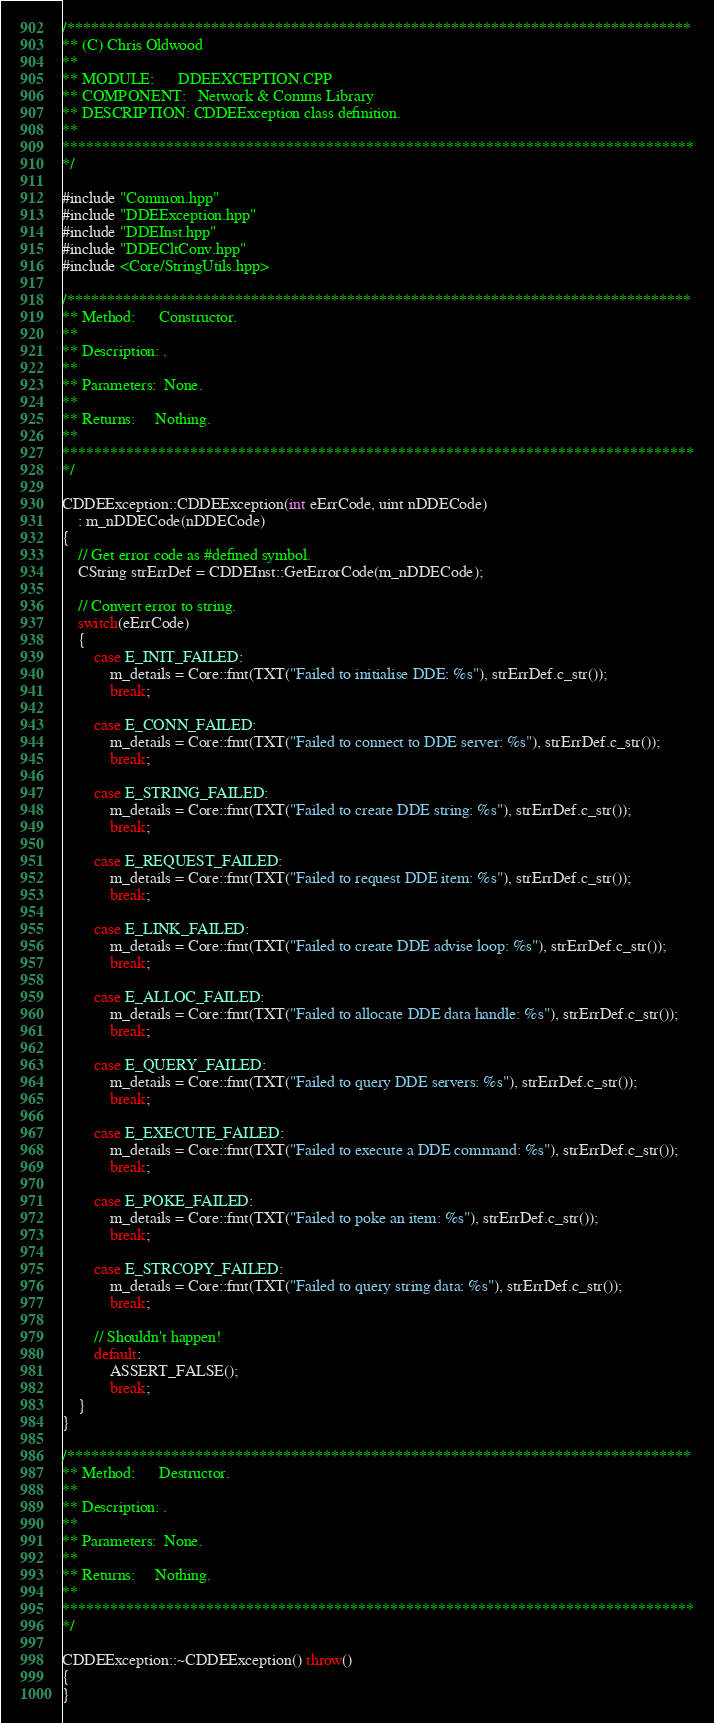<code> <loc_0><loc_0><loc_500><loc_500><_C++_>/******************************************************************************
** (C) Chris Oldwood
**
** MODULE:		DDEEXCEPTION.CPP
** COMPONENT:	Network & Comms Library
** DESCRIPTION:	CDDEException class definition.
**
*******************************************************************************
*/

#include "Common.hpp"
#include "DDEException.hpp"
#include "DDEInst.hpp"
#include "DDECltConv.hpp"
#include <Core/StringUtils.hpp>

/******************************************************************************
** Method:		Constructor.
**
** Description:	.
**
** Parameters:	None.
**
** Returns:		Nothing.
**
*******************************************************************************
*/

CDDEException::CDDEException(int eErrCode, uint nDDECode)
	: m_nDDECode(nDDECode)
{
	// Get error code as #defined symbol.
	CString strErrDef = CDDEInst::GetErrorCode(m_nDDECode);

	// Convert error to string.
	switch(eErrCode)
	{
		case E_INIT_FAILED:
			m_details = Core::fmt(TXT("Failed to initialise DDE: %s"), strErrDef.c_str());
			break;

		case E_CONN_FAILED:
			m_details = Core::fmt(TXT("Failed to connect to DDE server: %s"), strErrDef.c_str());
			break;

		case E_STRING_FAILED:
			m_details = Core::fmt(TXT("Failed to create DDE string: %s"), strErrDef.c_str());
			break;

		case E_REQUEST_FAILED:
			m_details = Core::fmt(TXT("Failed to request DDE item: %s"), strErrDef.c_str());
			break;

		case E_LINK_FAILED:
			m_details = Core::fmt(TXT("Failed to create DDE advise loop: %s"), strErrDef.c_str());
			break;

		case E_ALLOC_FAILED:
			m_details = Core::fmt(TXT("Failed to allocate DDE data handle: %s"), strErrDef.c_str());
			break;

		case E_QUERY_FAILED:
			m_details = Core::fmt(TXT("Failed to query DDE servers: %s"), strErrDef.c_str());
			break;

		case E_EXECUTE_FAILED:
			m_details = Core::fmt(TXT("Failed to execute a DDE command: %s"), strErrDef.c_str());
			break;

		case E_POKE_FAILED:
			m_details = Core::fmt(TXT("Failed to poke an item: %s"), strErrDef.c_str());
			break;

		case E_STRCOPY_FAILED:
			m_details = Core::fmt(TXT("Failed to query string data: %s"), strErrDef.c_str());
			break;

		// Shouldn't happen!
		default:
			ASSERT_FALSE();
			break;
	}
}

/******************************************************************************
** Method:		Destructor.
**
** Description:	.
**
** Parameters:	None.
**
** Returns:		Nothing.
**
*******************************************************************************
*/

CDDEException::~CDDEException() throw()
{
}
</code> 